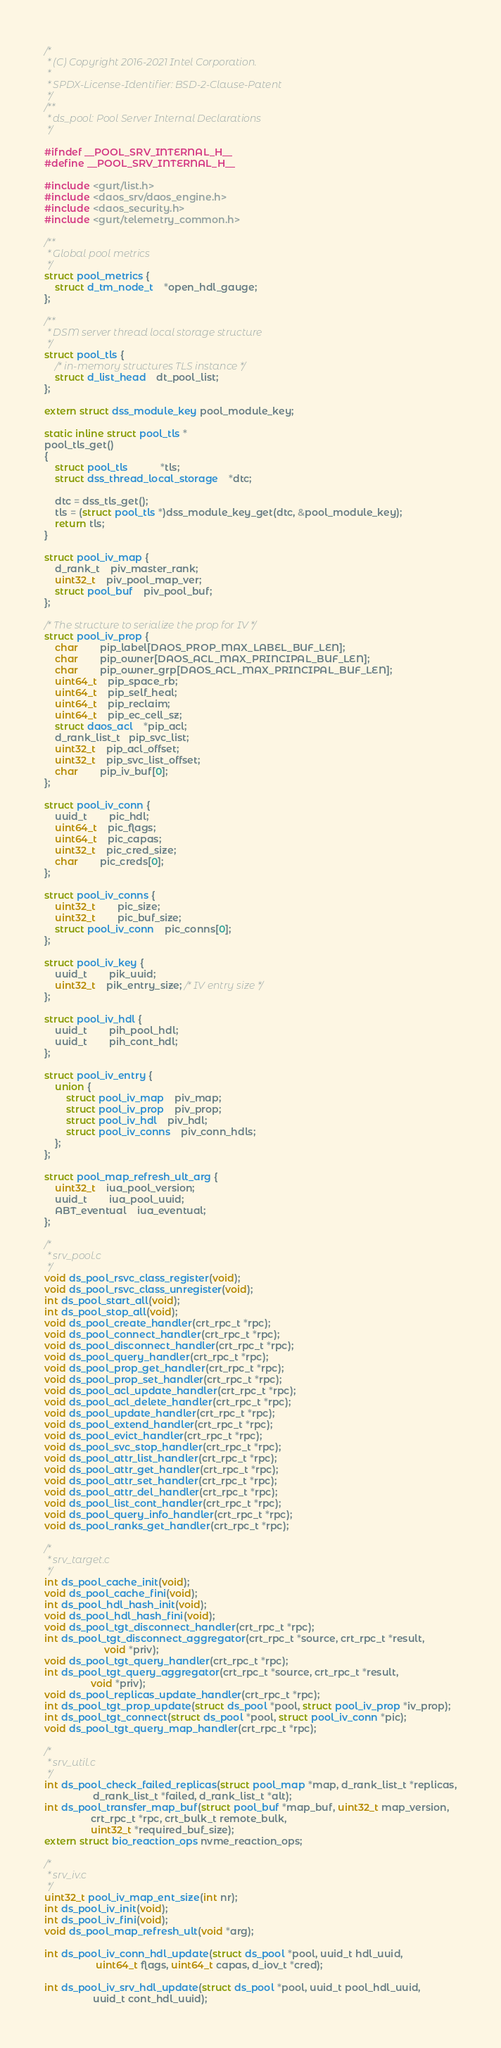Convert code to text. <code><loc_0><loc_0><loc_500><loc_500><_C_>/*
 * (C) Copyright 2016-2021 Intel Corporation.
 *
 * SPDX-License-Identifier: BSD-2-Clause-Patent
 */
/**
 * ds_pool: Pool Server Internal Declarations
 */

#ifndef __POOL_SRV_INTERNAL_H__
#define __POOL_SRV_INTERNAL_H__

#include <gurt/list.h>
#include <daos_srv/daos_engine.h>
#include <daos_security.h>
#include <gurt/telemetry_common.h>

/**
 * Global pool metrics
 */
struct pool_metrics {
	struct d_tm_node_t	*open_hdl_gauge;
};

/**
 * DSM server thread local storage structure
 */
struct pool_tls {
	/* in-memory structures TLS instance */
	struct d_list_head	dt_pool_list;
};

extern struct dss_module_key pool_module_key;

static inline struct pool_tls *
pool_tls_get()
{
	struct pool_tls			*tls;
	struct dss_thread_local_storage	*dtc;

	dtc = dss_tls_get();
	tls = (struct pool_tls *)dss_module_key_get(dtc, &pool_module_key);
	return tls;
}

struct pool_iv_map {
	d_rank_t	piv_master_rank;
	uint32_t	piv_pool_map_ver;
	struct pool_buf	piv_pool_buf;
};

/* The structure to serialize the prop for IV */
struct pool_iv_prop {
	char		pip_label[DAOS_PROP_MAX_LABEL_BUF_LEN];
	char		pip_owner[DAOS_ACL_MAX_PRINCIPAL_BUF_LEN];
	char		pip_owner_grp[DAOS_ACL_MAX_PRINCIPAL_BUF_LEN];
	uint64_t	pip_space_rb;
	uint64_t	pip_self_heal;
	uint64_t	pip_reclaim;
	uint64_t	pip_ec_cell_sz;
	struct daos_acl	*pip_acl;
	d_rank_list_t   pip_svc_list;
	uint32_t	pip_acl_offset;
	uint32_t	pip_svc_list_offset;
	char		pip_iv_buf[0];
};

struct pool_iv_conn {
	uuid_t		pic_hdl;
	uint64_t	pic_flags;
	uint64_t	pic_capas;
	uint32_t	pic_cred_size;
	char		pic_creds[0];
};

struct pool_iv_conns {
	uint32_t		pic_size;
	uint32_t		pic_buf_size;
	struct pool_iv_conn	pic_conns[0];
};

struct pool_iv_key {
	uuid_t		pik_uuid;
	uint32_t	pik_entry_size; /* IV entry size */
};

struct pool_iv_hdl {
	uuid_t		pih_pool_hdl;
	uuid_t		pih_cont_hdl;
};

struct pool_iv_entry {
	union {
		struct pool_iv_map	piv_map;
		struct pool_iv_prop	piv_prop;
		struct pool_iv_hdl	piv_hdl;
		struct pool_iv_conns	piv_conn_hdls;
	};
};

struct pool_map_refresh_ult_arg {
	uint32_t	iua_pool_version;
	uuid_t		iua_pool_uuid;
	ABT_eventual	iua_eventual;
};

/*
 * srv_pool.c
 */
void ds_pool_rsvc_class_register(void);
void ds_pool_rsvc_class_unregister(void);
int ds_pool_start_all(void);
int ds_pool_stop_all(void);
void ds_pool_create_handler(crt_rpc_t *rpc);
void ds_pool_connect_handler(crt_rpc_t *rpc);
void ds_pool_disconnect_handler(crt_rpc_t *rpc);
void ds_pool_query_handler(crt_rpc_t *rpc);
void ds_pool_prop_get_handler(crt_rpc_t *rpc);
void ds_pool_prop_set_handler(crt_rpc_t *rpc);
void ds_pool_acl_update_handler(crt_rpc_t *rpc);
void ds_pool_acl_delete_handler(crt_rpc_t *rpc);
void ds_pool_update_handler(crt_rpc_t *rpc);
void ds_pool_extend_handler(crt_rpc_t *rpc);
void ds_pool_evict_handler(crt_rpc_t *rpc);
void ds_pool_svc_stop_handler(crt_rpc_t *rpc);
void ds_pool_attr_list_handler(crt_rpc_t *rpc);
void ds_pool_attr_get_handler(crt_rpc_t *rpc);
void ds_pool_attr_set_handler(crt_rpc_t *rpc);
void ds_pool_attr_del_handler(crt_rpc_t *rpc);
void ds_pool_list_cont_handler(crt_rpc_t *rpc);
void ds_pool_query_info_handler(crt_rpc_t *rpc);
void ds_pool_ranks_get_handler(crt_rpc_t *rpc);

/*
 * srv_target.c
 */
int ds_pool_cache_init(void);
void ds_pool_cache_fini(void);
int ds_pool_hdl_hash_init(void);
void ds_pool_hdl_hash_fini(void);
void ds_pool_tgt_disconnect_handler(crt_rpc_t *rpc);
int ds_pool_tgt_disconnect_aggregator(crt_rpc_t *source, crt_rpc_t *result,
				      void *priv);
void ds_pool_tgt_query_handler(crt_rpc_t *rpc);
int ds_pool_tgt_query_aggregator(crt_rpc_t *source, crt_rpc_t *result,
				 void *priv);
void ds_pool_replicas_update_handler(crt_rpc_t *rpc);
int ds_pool_tgt_prop_update(struct ds_pool *pool, struct pool_iv_prop *iv_prop);
int ds_pool_tgt_connect(struct ds_pool *pool, struct pool_iv_conn *pic);
void ds_pool_tgt_query_map_handler(crt_rpc_t *rpc);

/*
 * srv_util.c
 */
int ds_pool_check_failed_replicas(struct pool_map *map, d_rank_list_t *replicas,
				  d_rank_list_t *failed, d_rank_list_t *alt);
int ds_pool_transfer_map_buf(struct pool_buf *map_buf, uint32_t map_version,
			     crt_rpc_t *rpc, crt_bulk_t remote_bulk,
			     uint32_t *required_buf_size);
extern struct bio_reaction_ops nvme_reaction_ops;

/*
 * srv_iv.c
 */
uint32_t pool_iv_map_ent_size(int nr);
int ds_pool_iv_init(void);
int ds_pool_iv_fini(void);
void ds_pool_map_refresh_ult(void *arg);

int ds_pool_iv_conn_hdl_update(struct ds_pool *pool, uuid_t hdl_uuid,
			       uint64_t flags, uint64_t capas, d_iov_t *cred);

int ds_pool_iv_srv_hdl_update(struct ds_pool *pool, uuid_t pool_hdl_uuid,
			      uuid_t cont_hdl_uuid);
</code> 